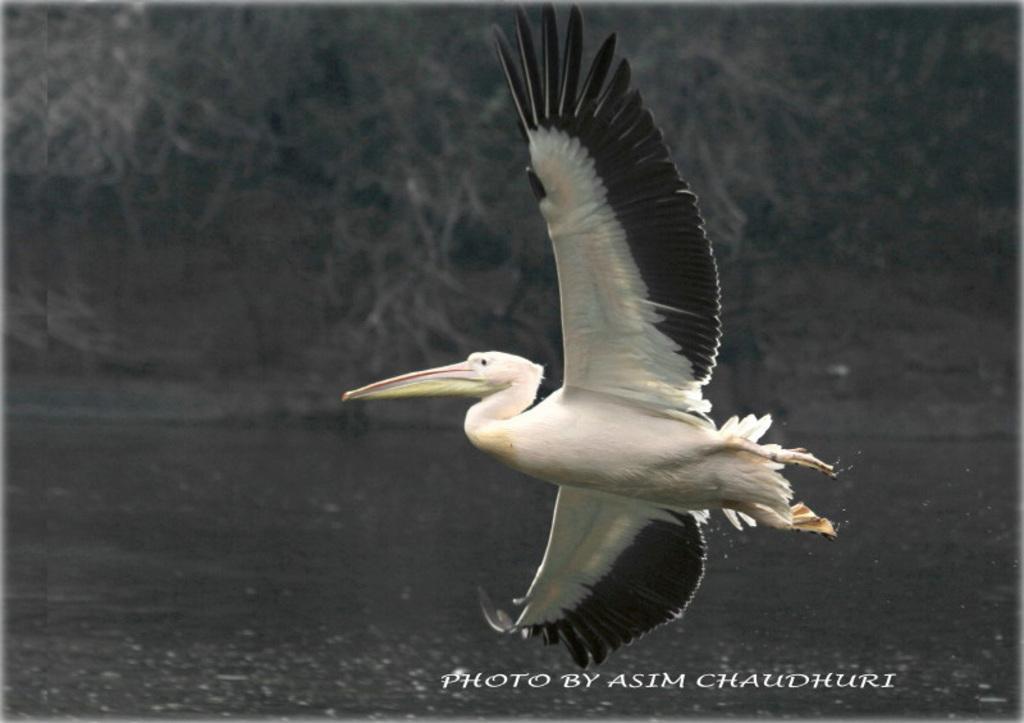How would you summarize this image in a sentence or two? In this image we can see a bird flying in the air. In the background there are trees and water. 